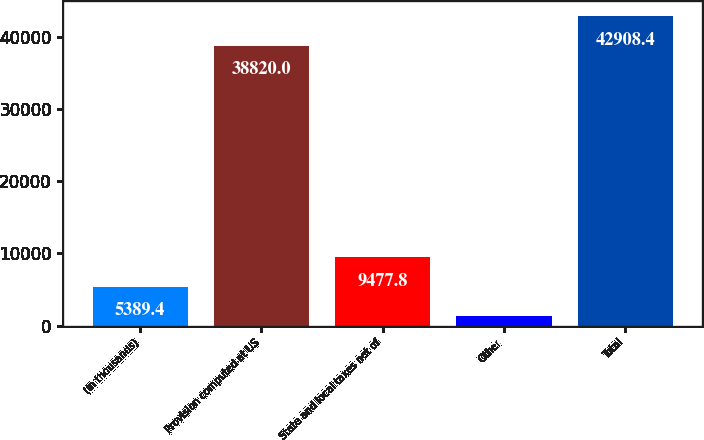<chart> <loc_0><loc_0><loc_500><loc_500><bar_chart><fcel>(In thousands)<fcel>Provision computed at US<fcel>State and local taxes net of<fcel>Other<fcel>Total<nl><fcel>5389.4<fcel>38820<fcel>9477.8<fcel>1301<fcel>42908.4<nl></chart> 